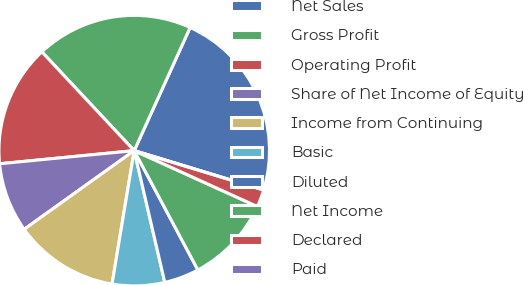Convert chart. <chart><loc_0><loc_0><loc_500><loc_500><pie_chart><fcel>Net Sales<fcel>Gross Profit<fcel>Operating Profit<fcel>Share of Net Income of Equity<fcel>Income from Continuing<fcel>Basic<fcel>Diluted<fcel>Net Income<fcel>Declared<fcel>Paid<nl><fcel>22.91%<fcel>18.75%<fcel>14.58%<fcel>8.33%<fcel>12.5%<fcel>6.25%<fcel>4.17%<fcel>10.42%<fcel>2.08%<fcel>0.0%<nl></chart> 